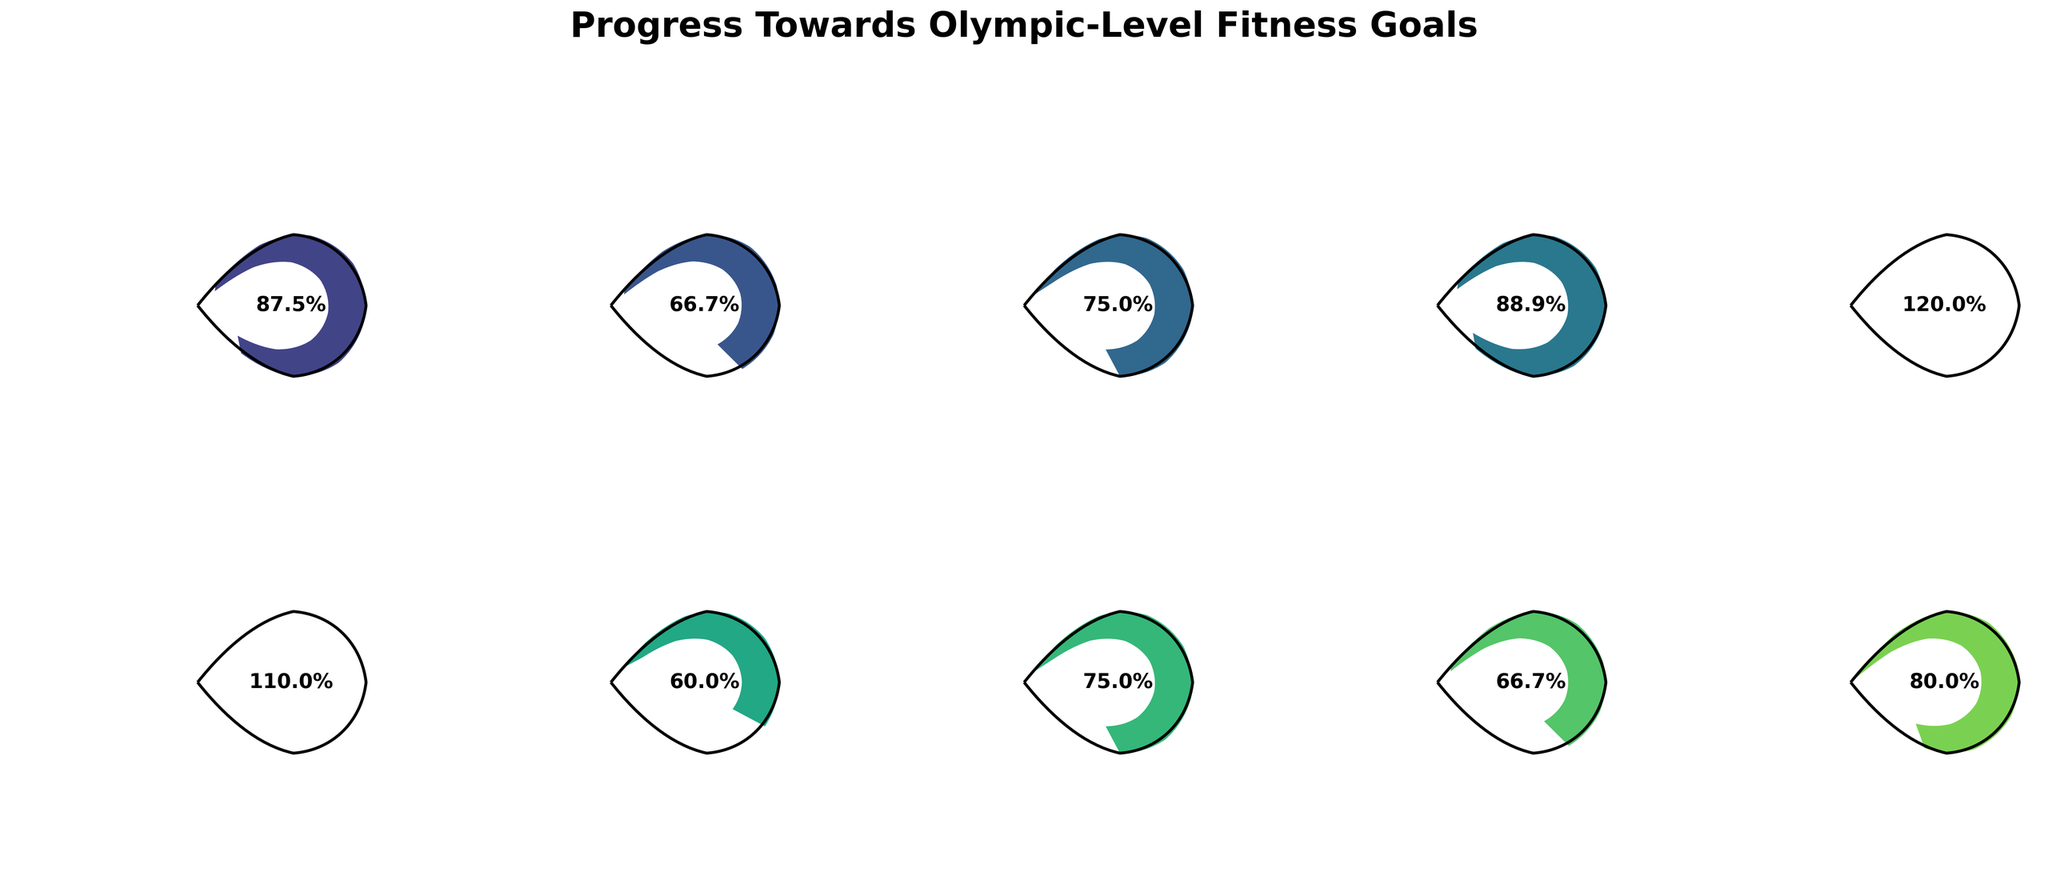What is the current daily calorie burn compared to the target? The gauge chart titled "Daily Calories Burned" indicates that the current value is 2800 calories and the target value is 3200 calories.
Answer: 2800/3200 Which fitness metric has the highest target value? Among all the metrics, "Monthly Volleyball Practice Hours" has the highest target value at 80 hours per month.
Answer: Monthly Volleyball Practice Hours How many high-intensity workouts should be added per week to meet the goal? The gauge chart titled "Weekly High-Intensity Workouts" indicates that the current value is 4 workouts and the target value is 6 workouts. To meet the goal, you should add 6 - 4 = 2 workouts per week.
Answer: 2 What percentage of the vertical jump height target has been achieved? The gauge chart for "Vertical Jump Height" shows the current value is 32 inches and the target value is 36 inches. The percentage achieved is (32 / 36) * 100 = 88.9%.
Answer: 88.9% Which metric is closest to reaching its target value? Comparing all the gauge charts, "Vertical Jump Height" shows the highest percentage completion, with 88.9% achieved.
Answer: Vertical Jump Height What is the difference between the current and target body fat percentage? The gauge chart for "Body Fat Percentage" indicates the current value is 12% and the target value is 10%. The difference is 12% - 10% = 2%.
Answer: 2% Which metric has the lowest percentage achievement towards the target? The gauge chart with the lowest percentage achievement is "Flexibility Training Minutes per Day," showing 30 minutes out of a target of 45 minutes, which is (30 / 45) * 100 = 66.7%.
Answer: Flexibility Training Minutes per Day How much higher should the protein intake be to meet the goal? The gauge chart titled "Protein Intake (grams per day)" shows the current value is 120 grams, and the target value is 150 grams. To meet the goal, the intake should increase by 150 - 120 = 30 grams.
Answer: 30 What is the combined target for the number of strength training sessions and high-intensity workouts per week? The target for "Strength Training Sessions per Week" is 5 sessions, and the target for "Weekly High-Intensity Workouts" is 6 sessions. Combined, the target is 5 + 6 = 11 sessions per week.
Answer: 11 Which fitness metric has the smallest difference between the current and target values in absolute terms? Among all the metrics, "Resting Heart Rate" has the smallest difference between the current value (55 bpm) and target value (50 bpm), with an absolute difference of 55 - 50 = 5 bpm.
Answer: Resting Heart Rate 